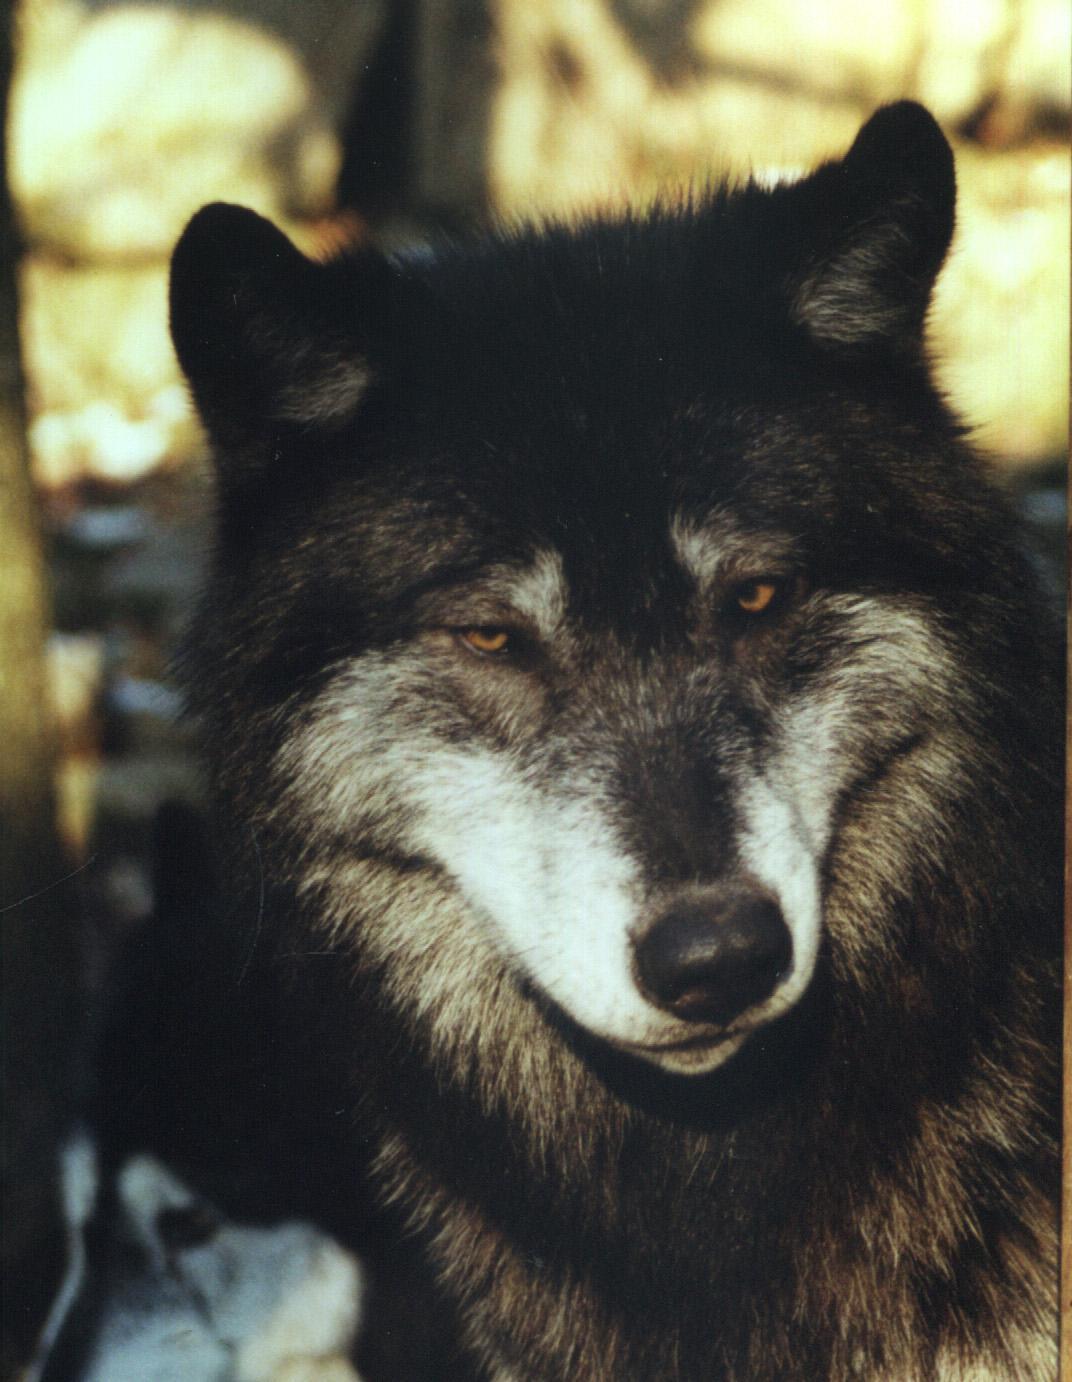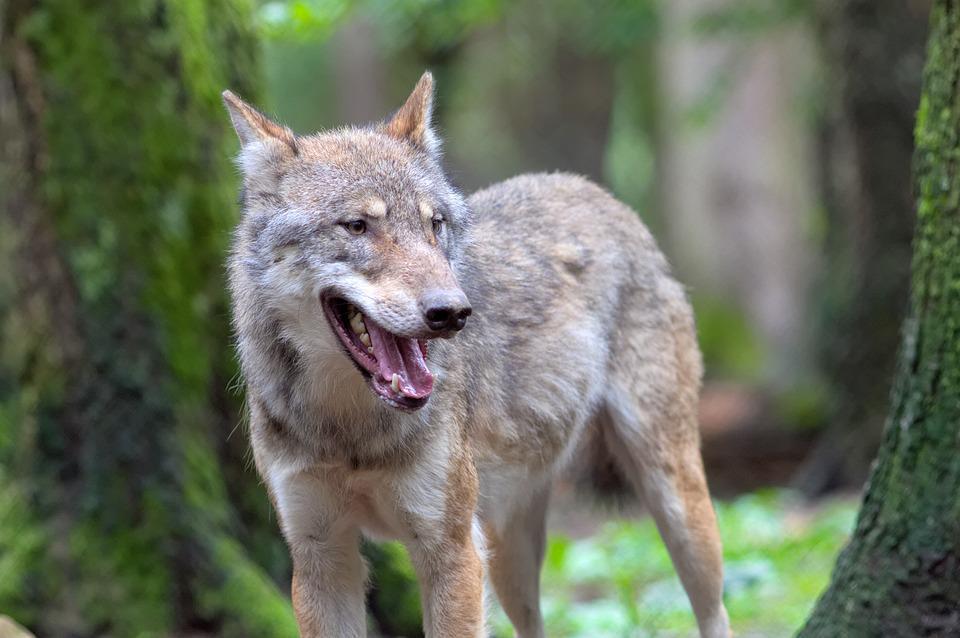The first image is the image on the left, the second image is the image on the right. For the images shown, is this caption "One of the dogs is black with a white muzzle." true? Answer yes or no. Yes. The first image is the image on the left, the second image is the image on the right. Given the left and right images, does the statement "One of the wolves' teeth are visible." hold true? Answer yes or no. Yes. 